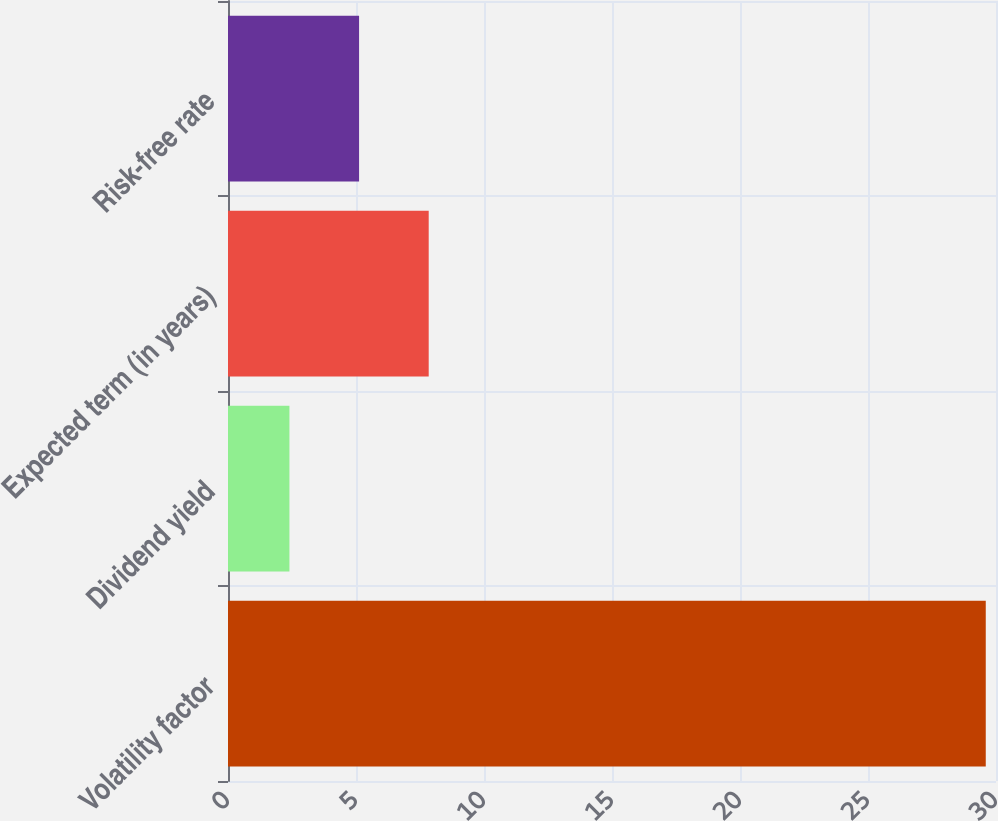<chart> <loc_0><loc_0><loc_500><loc_500><bar_chart><fcel>Volatility factor<fcel>Dividend yield<fcel>Expected term (in years)<fcel>Risk-free rate<nl><fcel>29.6<fcel>2.4<fcel>7.84<fcel>5.12<nl></chart> 